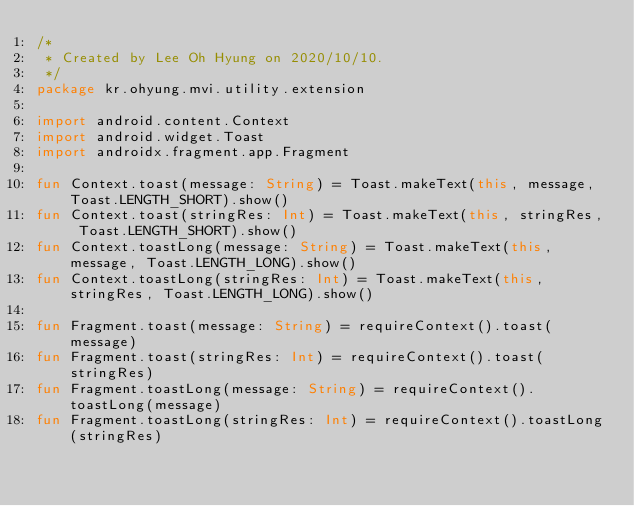Convert code to text. <code><loc_0><loc_0><loc_500><loc_500><_Kotlin_>/*
 * Created by Lee Oh Hyung on 2020/10/10.
 */
package kr.ohyung.mvi.utility.extension

import android.content.Context
import android.widget.Toast
import androidx.fragment.app.Fragment

fun Context.toast(message: String) = Toast.makeText(this, message, Toast.LENGTH_SHORT).show()
fun Context.toast(stringRes: Int) = Toast.makeText(this, stringRes, Toast.LENGTH_SHORT).show()
fun Context.toastLong(message: String) = Toast.makeText(this, message, Toast.LENGTH_LONG).show()
fun Context.toastLong(stringRes: Int) = Toast.makeText(this, stringRes, Toast.LENGTH_LONG).show()

fun Fragment.toast(message: String) = requireContext().toast(message)
fun Fragment.toast(stringRes: Int) = requireContext().toast(stringRes)
fun Fragment.toastLong(message: String) = requireContext().toastLong(message)
fun Fragment.toastLong(stringRes: Int) = requireContext().toastLong(stringRes)
</code> 